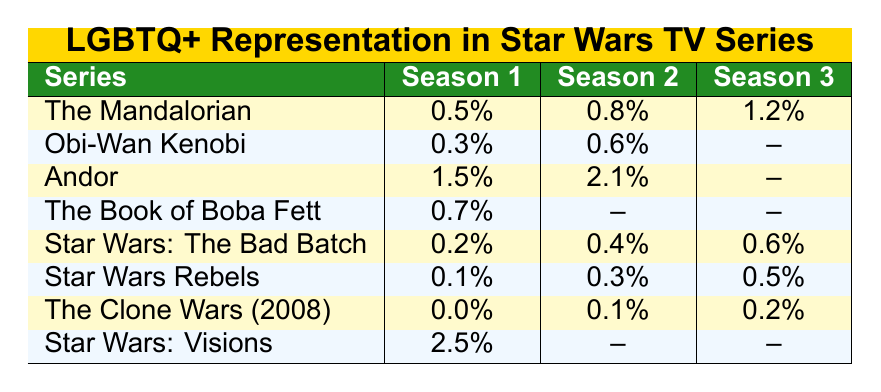What is the percentage of screen time for LGBTQ+ characters in "The Mandalorian" Season 1? The table shows that "The Mandalorian" has 0.5% screen time for LGBTQ+ characters in Season 1.
Answer: 0.5% Which series has the highest percentage of screen time for LGBTQ+ characters in Season 2? In Season 2, "Andor" has 2.1%, which is the highest percentage according to the table.
Answer: Andor What is the average percentage of screen time for LGBTQ+ characters across all seasons for "Star Wars: The Bad Batch"? The values for "Star Wars: The Bad Batch" are 0.2%, 0.4%, and 0.6%. The average is (0.2 + 0.4 + 0.6) / 3 = 1.2 / 3 = 0.4%.
Answer: 0.4% Is there any season for "Star Wars Rebels" where LGBTQ+ characters don't have screen time? The third season of "Star Wars Rebels" has no value, indicated by the presence of a 0.5% in Season 1 and 0.3% in Season 2 but no value in Season 3, which implies no screen time for LGBTQ+ characters.
Answer: Yes How does the screen time for LGBTQ+ characters in "Star Wars: Visions" compare to "The Clone Wars (2008)" in terms of percentage? "Star Wars: Visions" has 2.5% for season 1, while "The Clone Wars (2008)" has 0.0% in season 1, meaning "Visions" significantly exceeds "The Clone Wars" in LGBTQ+ representation.
Answer: Visions has more screen time What is the total percentage of screen time for LGBTQ+ characters across all seasons in "Obi-Wan Kenobi"? The percentages are 0.3% and 0.6% for Season 1 and Season 2 respectively. The total is 0.3 + 0.6 = 0.9%. However, Season 3 has no value, so it does not contribute.
Answer: 0.9% Which series has consistently increasing values in the percentages across the seasons? "Andor" shows increasing values from 1.5% in Season 1 to 2.1% in Season 2.
Answer: Andor What is the difference in LGBTQ+ screen time between "The Mandalorian" Season 3 and "The Book of Boba Fett" Season 1? "The Mandalorian" Season 3 has a percentage of 1.2%, whereas "The Book of Boba Fett" Season 1 has 0.7%. The difference is 1.2% - 0.7% = 0.5%.
Answer: 0.5% 